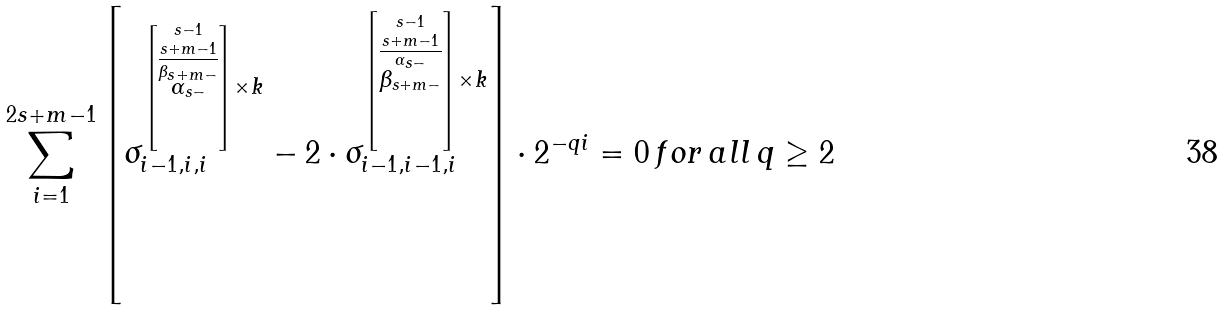Convert formula to latex. <formula><loc_0><loc_0><loc_500><loc_500>\sum _ { i = 1 } ^ { 2 s + m - 1 } \left [ \sigma _ { i - 1 , i , i } ^ { \left [ \stackrel { s - 1 } { \stackrel { s + m - 1 } { \overline { \stackrel { \beta _ { s + m - } } { \alpha _ { s - } } } } } \right ] \times k } - 2 \cdot \sigma _ { i - 1 , i - 1 , i } ^ { \left [ \stackrel { s - 1 } { \stackrel { s + m - 1 } { \overline { \stackrel { \alpha _ { s - } } { \beta _ { s + m - } } } } } \right ] \times k } \right ] \cdot 2 ^ { - q i } = 0 \, f o r \, a l l \, q \geq 2</formula> 